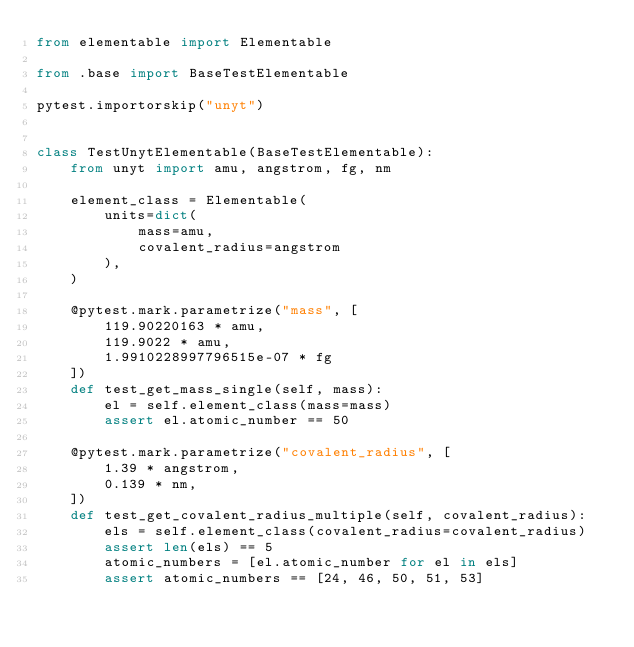<code> <loc_0><loc_0><loc_500><loc_500><_Python_>from elementable import Elementable

from .base import BaseTestElementable

pytest.importorskip("unyt")


class TestUnytElementable(BaseTestElementable):
    from unyt import amu, angstrom, fg, nm

    element_class = Elementable(
        units=dict(
            mass=amu,
            covalent_radius=angstrom
        ),
    )

    @pytest.mark.parametrize("mass", [
        119.90220163 * amu,
        119.9022 * amu,
        1.9910228997796515e-07 * fg
    ])
    def test_get_mass_single(self, mass):
        el = self.element_class(mass=mass)
        assert el.atomic_number == 50

    @pytest.mark.parametrize("covalent_radius", [
        1.39 * angstrom,
        0.139 * nm,
    ])
    def test_get_covalent_radius_multiple(self, covalent_radius):
        els = self.element_class(covalent_radius=covalent_radius)
        assert len(els) == 5
        atomic_numbers = [el.atomic_number for el in els]
        assert atomic_numbers == [24, 46, 50, 51, 53]
</code> 